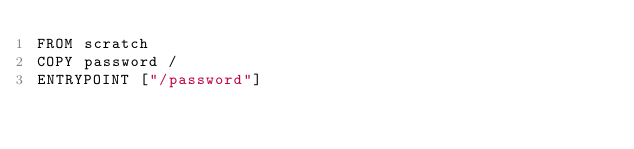Convert code to text. <code><loc_0><loc_0><loc_500><loc_500><_Dockerfile_>FROM scratch
COPY password /
ENTRYPOINT ["/password"]
</code> 